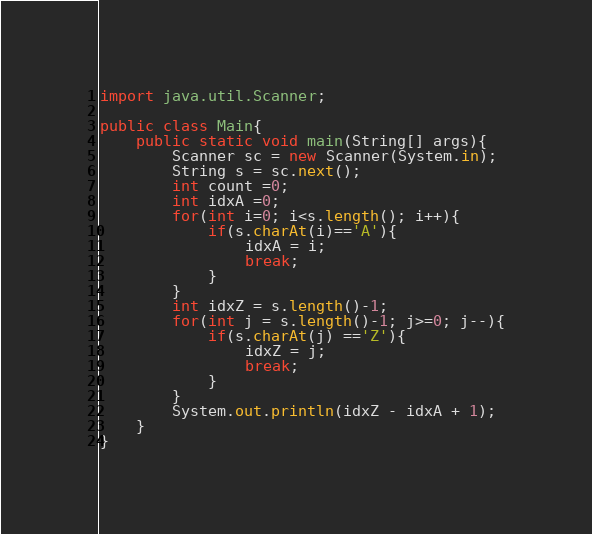<code> <loc_0><loc_0><loc_500><loc_500><_Java_>import java.util.Scanner;

public class Main{
	public static void main(String[] args){
 		Scanner sc = new Scanner(System.in);
 		String s = sc.next();
 		int count =0;
 		int idxA =0;
 		for(int i=0; i<s.length(); i++){
 			if(s.charAt(i)=='A'){
 				idxA = i;
 				break;
 			}
 		}
 		int idxZ = s.length()-1;
 		for(int j = s.length()-1; j>=0; j--){
 			if(s.charAt(j) =='Z'){
 				idxZ = j;
 				break;
 			}
 		}
 		System.out.println(idxZ - idxA + 1);
 	}
} </code> 